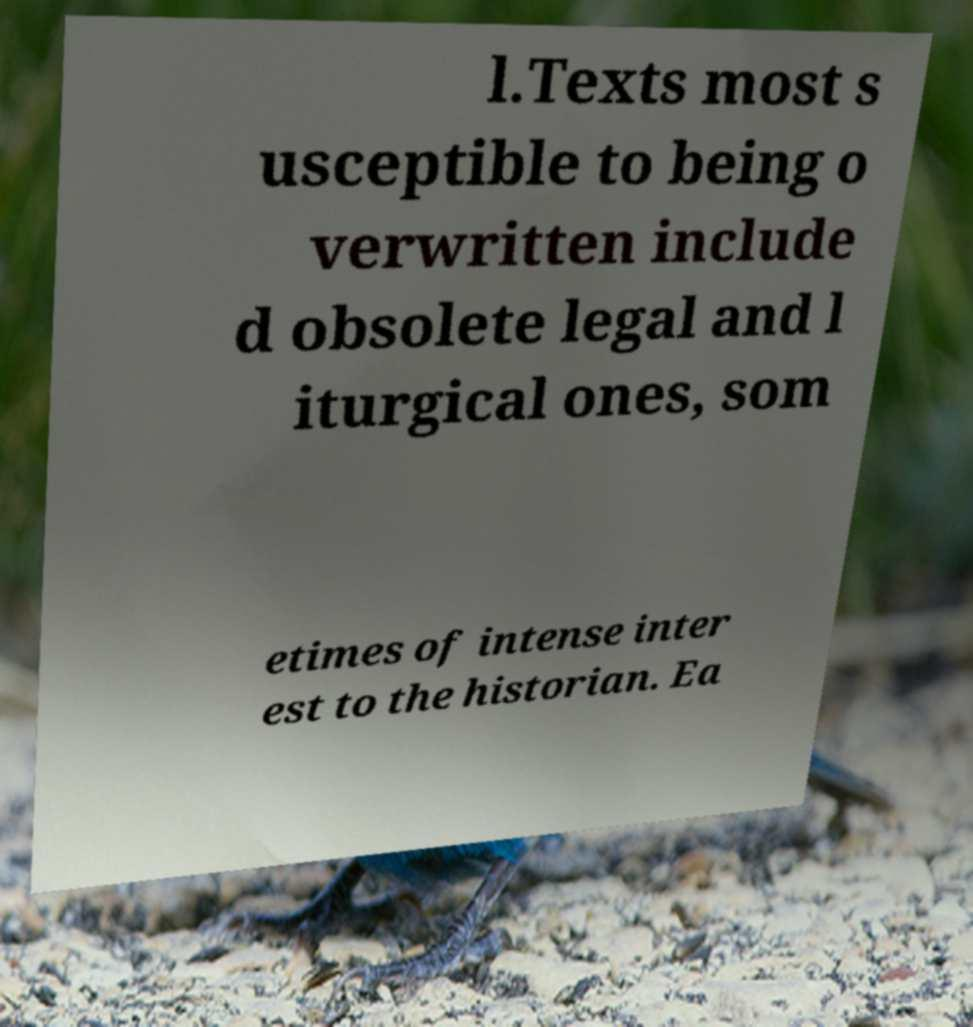Please identify and transcribe the text found in this image. l.Texts most s usceptible to being o verwritten include d obsolete legal and l iturgical ones, som etimes of intense inter est to the historian. Ea 